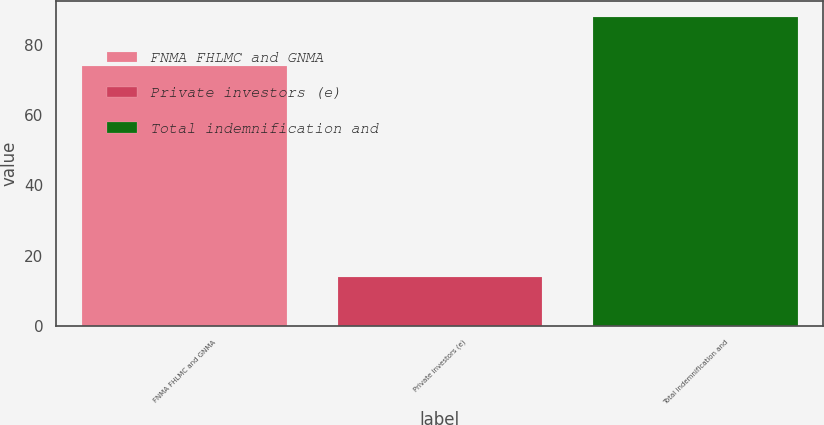Convert chart to OTSL. <chart><loc_0><loc_0><loc_500><loc_500><bar_chart><fcel>FNMA FHLMC and GNMA<fcel>Private investors (e)<fcel>Total indemnification and<nl><fcel>74<fcel>14<fcel>88<nl></chart> 